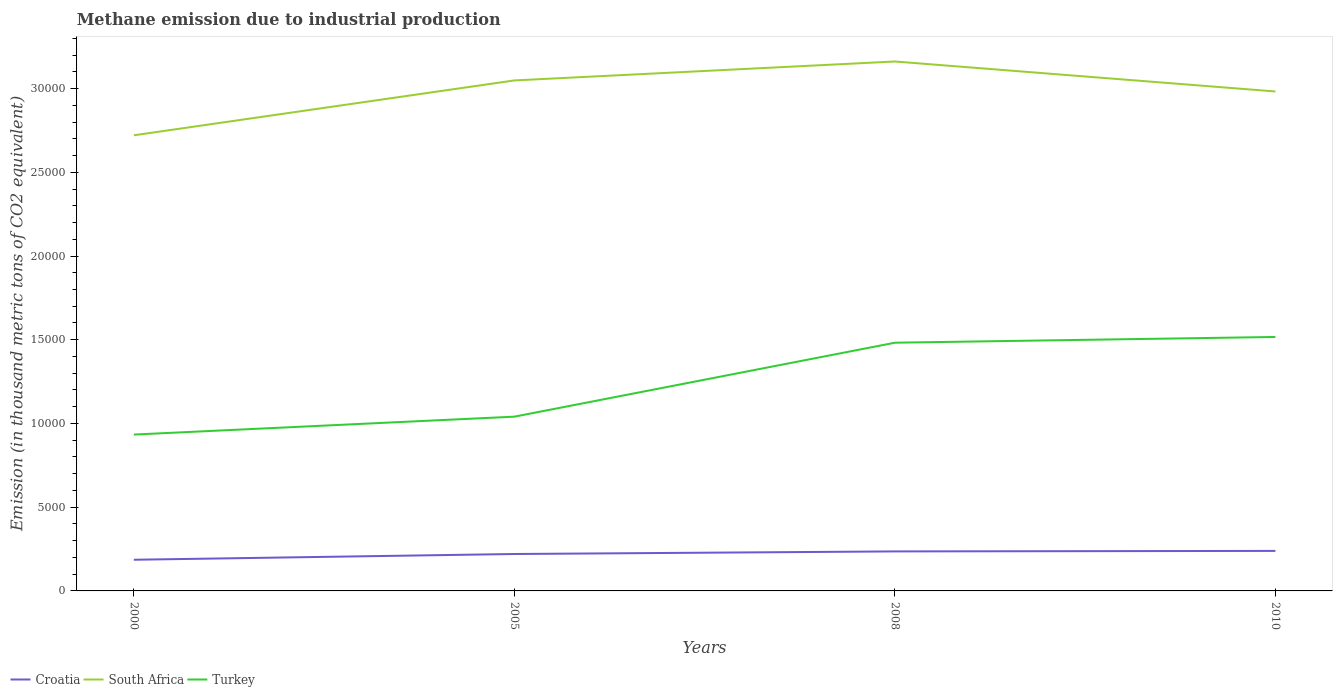Across all years, what is the maximum amount of methane emitted in Croatia?
Offer a very short reply. 1861.7. What is the total amount of methane emitted in Croatia in the graph?
Ensure brevity in your answer.  -184.8. What is the difference between the highest and the second highest amount of methane emitted in Croatia?
Make the answer very short. 527.6. What is the difference between the highest and the lowest amount of methane emitted in Croatia?
Provide a short and direct response. 3. What is the difference between two consecutive major ticks on the Y-axis?
Provide a short and direct response. 5000. Are the values on the major ticks of Y-axis written in scientific E-notation?
Offer a terse response. No. Does the graph contain any zero values?
Your answer should be compact. No. Does the graph contain grids?
Offer a terse response. No. Where does the legend appear in the graph?
Offer a terse response. Bottom left. How are the legend labels stacked?
Offer a terse response. Horizontal. What is the title of the graph?
Offer a very short reply. Methane emission due to industrial production. Does "Andorra" appear as one of the legend labels in the graph?
Your answer should be compact. No. What is the label or title of the X-axis?
Ensure brevity in your answer.  Years. What is the label or title of the Y-axis?
Give a very brief answer. Emission (in thousand metric tons of CO2 equivalent). What is the Emission (in thousand metric tons of CO2 equivalent) of Croatia in 2000?
Give a very brief answer. 1861.7. What is the Emission (in thousand metric tons of CO2 equivalent) of South Africa in 2000?
Make the answer very short. 2.72e+04. What is the Emission (in thousand metric tons of CO2 equivalent) of Turkey in 2000?
Ensure brevity in your answer.  9337. What is the Emission (in thousand metric tons of CO2 equivalent) in Croatia in 2005?
Your answer should be compact. 2204.5. What is the Emission (in thousand metric tons of CO2 equivalent) in South Africa in 2005?
Your response must be concise. 3.05e+04. What is the Emission (in thousand metric tons of CO2 equivalent) in Turkey in 2005?
Make the answer very short. 1.04e+04. What is the Emission (in thousand metric tons of CO2 equivalent) in Croatia in 2008?
Give a very brief answer. 2359.2. What is the Emission (in thousand metric tons of CO2 equivalent) of South Africa in 2008?
Give a very brief answer. 3.16e+04. What is the Emission (in thousand metric tons of CO2 equivalent) in Turkey in 2008?
Make the answer very short. 1.48e+04. What is the Emission (in thousand metric tons of CO2 equivalent) of Croatia in 2010?
Ensure brevity in your answer.  2389.3. What is the Emission (in thousand metric tons of CO2 equivalent) of South Africa in 2010?
Make the answer very short. 2.98e+04. What is the Emission (in thousand metric tons of CO2 equivalent) in Turkey in 2010?
Give a very brief answer. 1.52e+04. Across all years, what is the maximum Emission (in thousand metric tons of CO2 equivalent) of Croatia?
Offer a terse response. 2389.3. Across all years, what is the maximum Emission (in thousand metric tons of CO2 equivalent) of South Africa?
Offer a terse response. 3.16e+04. Across all years, what is the maximum Emission (in thousand metric tons of CO2 equivalent) in Turkey?
Make the answer very short. 1.52e+04. Across all years, what is the minimum Emission (in thousand metric tons of CO2 equivalent) in Croatia?
Offer a terse response. 1861.7. Across all years, what is the minimum Emission (in thousand metric tons of CO2 equivalent) of South Africa?
Give a very brief answer. 2.72e+04. Across all years, what is the minimum Emission (in thousand metric tons of CO2 equivalent) of Turkey?
Provide a succinct answer. 9337. What is the total Emission (in thousand metric tons of CO2 equivalent) of Croatia in the graph?
Offer a very short reply. 8814.7. What is the total Emission (in thousand metric tons of CO2 equivalent) in South Africa in the graph?
Provide a short and direct response. 1.19e+05. What is the total Emission (in thousand metric tons of CO2 equivalent) of Turkey in the graph?
Your answer should be compact. 4.97e+04. What is the difference between the Emission (in thousand metric tons of CO2 equivalent) in Croatia in 2000 and that in 2005?
Offer a terse response. -342.8. What is the difference between the Emission (in thousand metric tons of CO2 equivalent) in South Africa in 2000 and that in 2005?
Your response must be concise. -3276.5. What is the difference between the Emission (in thousand metric tons of CO2 equivalent) of Turkey in 2000 and that in 2005?
Provide a short and direct response. -1069.4. What is the difference between the Emission (in thousand metric tons of CO2 equivalent) of Croatia in 2000 and that in 2008?
Your response must be concise. -497.5. What is the difference between the Emission (in thousand metric tons of CO2 equivalent) in South Africa in 2000 and that in 2008?
Provide a short and direct response. -4407.6. What is the difference between the Emission (in thousand metric tons of CO2 equivalent) of Turkey in 2000 and that in 2008?
Ensure brevity in your answer.  -5485.1. What is the difference between the Emission (in thousand metric tons of CO2 equivalent) in Croatia in 2000 and that in 2010?
Your response must be concise. -527.6. What is the difference between the Emission (in thousand metric tons of CO2 equivalent) of South Africa in 2000 and that in 2010?
Keep it short and to the point. -2616.9. What is the difference between the Emission (in thousand metric tons of CO2 equivalent) of Turkey in 2000 and that in 2010?
Give a very brief answer. -5828.6. What is the difference between the Emission (in thousand metric tons of CO2 equivalent) in Croatia in 2005 and that in 2008?
Your response must be concise. -154.7. What is the difference between the Emission (in thousand metric tons of CO2 equivalent) of South Africa in 2005 and that in 2008?
Your answer should be very brief. -1131.1. What is the difference between the Emission (in thousand metric tons of CO2 equivalent) in Turkey in 2005 and that in 2008?
Give a very brief answer. -4415.7. What is the difference between the Emission (in thousand metric tons of CO2 equivalent) of Croatia in 2005 and that in 2010?
Provide a succinct answer. -184.8. What is the difference between the Emission (in thousand metric tons of CO2 equivalent) in South Africa in 2005 and that in 2010?
Your answer should be compact. 659.6. What is the difference between the Emission (in thousand metric tons of CO2 equivalent) of Turkey in 2005 and that in 2010?
Offer a terse response. -4759.2. What is the difference between the Emission (in thousand metric tons of CO2 equivalent) of Croatia in 2008 and that in 2010?
Offer a terse response. -30.1. What is the difference between the Emission (in thousand metric tons of CO2 equivalent) in South Africa in 2008 and that in 2010?
Make the answer very short. 1790.7. What is the difference between the Emission (in thousand metric tons of CO2 equivalent) in Turkey in 2008 and that in 2010?
Make the answer very short. -343.5. What is the difference between the Emission (in thousand metric tons of CO2 equivalent) of Croatia in 2000 and the Emission (in thousand metric tons of CO2 equivalent) of South Africa in 2005?
Offer a very short reply. -2.86e+04. What is the difference between the Emission (in thousand metric tons of CO2 equivalent) of Croatia in 2000 and the Emission (in thousand metric tons of CO2 equivalent) of Turkey in 2005?
Your answer should be compact. -8544.7. What is the difference between the Emission (in thousand metric tons of CO2 equivalent) in South Africa in 2000 and the Emission (in thousand metric tons of CO2 equivalent) in Turkey in 2005?
Provide a short and direct response. 1.68e+04. What is the difference between the Emission (in thousand metric tons of CO2 equivalent) of Croatia in 2000 and the Emission (in thousand metric tons of CO2 equivalent) of South Africa in 2008?
Keep it short and to the point. -2.98e+04. What is the difference between the Emission (in thousand metric tons of CO2 equivalent) in Croatia in 2000 and the Emission (in thousand metric tons of CO2 equivalent) in Turkey in 2008?
Offer a very short reply. -1.30e+04. What is the difference between the Emission (in thousand metric tons of CO2 equivalent) in South Africa in 2000 and the Emission (in thousand metric tons of CO2 equivalent) in Turkey in 2008?
Provide a succinct answer. 1.24e+04. What is the difference between the Emission (in thousand metric tons of CO2 equivalent) in Croatia in 2000 and the Emission (in thousand metric tons of CO2 equivalent) in South Africa in 2010?
Ensure brevity in your answer.  -2.80e+04. What is the difference between the Emission (in thousand metric tons of CO2 equivalent) in Croatia in 2000 and the Emission (in thousand metric tons of CO2 equivalent) in Turkey in 2010?
Ensure brevity in your answer.  -1.33e+04. What is the difference between the Emission (in thousand metric tons of CO2 equivalent) in South Africa in 2000 and the Emission (in thousand metric tons of CO2 equivalent) in Turkey in 2010?
Offer a very short reply. 1.20e+04. What is the difference between the Emission (in thousand metric tons of CO2 equivalent) of Croatia in 2005 and the Emission (in thousand metric tons of CO2 equivalent) of South Africa in 2008?
Provide a succinct answer. -2.94e+04. What is the difference between the Emission (in thousand metric tons of CO2 equivalent) of Croatia in 2005 and the Emission (in thousand metric tons of CO2 equivalent) of Turkey in 2008?
Provide a succinct answer. -1.26e+04. What is the difference between the Emission (in thousand metric tons of CO2 equivalent) in South Africa in 2005 and the Emission (in thousand metric tons of CO2 equivalent) in Turkey in 2008?
Provide a succinct answer. 1.57e+04. What is the difference between the Emission (in thousand metric tons of CO2 equivalent) of Croatia in 2005 and the Emission (in thousand metric tons of CO2 equivalent) of South Africa in 2010?
Your answer should be very brief. -2.76e+04. What is the difference between the Emission (in thousand metric tons of CO2 equivalent) of Croatia in 2005 and the Emission (in thousand metric tons of CO2 equivalent) of Turkey in 2010?
Keep it short and to the point. -1.30e+04. What is the difference between the Emission (in thousand metric tons of CO2 equivalent) in South Africa in 2005 and the Emission (in thousand metric tons of CO2 equivalent) in Turkey in 2010?
Ensure brevity in your answer.  1.53e+04. What is the difference between the Emission (in thousand metric tons of CO2 equivalent) of Croatia in 2008 and the Emission (in thousand metric tons of CO2 equivalent) of South Africa in 2010?
Your answer should be compact. -2.75e+04. What is the difference between the Emission (in thousand metric tons of CO2 equivalent) in Croatia in 2008 and the Emission (in thousand metric tons of CO2 equivalent) in Turkey in 2010?
Offer a very short reply. -1.28e+04. What is the difference between the Emission (in thousand metric tons of CO2 equivalent) in South Africa in 2008 and the Emission (in thousand metric tons of CO2 equivalent) in Turkey in 2010?
Your response must be concise. 1.64e+04. What is the average Emission (in thousand metric tons of CO2 equivalent) in Croatia per year?
Offer a very short reply. 2203.68. What is the average Emission (in thousand metric tons of CO2 equivalent) in South Africa per year?
Your response must be concise. 2.98e+04. What is the average Emission (in thousand metric tons of CO2 equivalent) of Turkey per year?
Provide a short and direct response. 1.24e+04. In the year 2000, what is the difference between the Emission (in thousand metric tons of CO2 equivalent) in Croatia and Emission (in thousand metric tons of CO2 equivalent) in South Africa?
Offer a terse response. -2.53e+04. In the year 2000, what is the difference between the Emission (in thousand metric tons of CO2 equivalent) of Croatia and Emission (in thousand metric tons of CO2 equivalent) of Turkey?
Keep it short and to the point. -7475.3. In the year 2000, what is the difference between the Emission (in thousand metric tons of CO2 equivalent) of South Africa and Emission (in thousand metric tons of CO2 equivalent) of Turkey?
Offer a terse response. 1.79e+04. In the year 2005, what is the difference between the Emission (in thousand metric tons of CO2 equivalent) in Croatia and Emission (in thousand metric tons of CO2 equivalent) in South Africa?
Give a very brief answer. -2.83e+04. In the year 2005, what is the difference between the Emission (in thousand metric tons of CO2 equivalent) in Croatia and Emission (in thousand metric tons of CO2 equivalent) in Turkey?
Offer a terse response. -8201.9. In the year 2005, what is the difference between the Emission (in thousand metric tons of CO2 equivalent) of South Africa and Emission (in thousand metric tons of CO2 equivalent) of Turkey?
Make the answer very short. 2.01e+04. In the year 2008, what is the difference between the Emission (in thousand metric tons of CO2 equivalent) of Croatia and Emission (in thousand metric tons of CO2 equivalent) of South Africa?
Make the answer very short. -2.93e+04. In the year 2008, what is the difference between the Emission (in thousand metric tons of CO2 equivalent) in Croatia and Emission (in thousand metric tons of CO2 equivalent) in Turkey?
Your answer should be compact. -1.25e+04. In the year 2008, what is the difference between the Emission (in thousand metric tons of CO2 equivalent) of South Africa and Emission (in thousand metric tons of CO2 equivalent) of Turkey?
Keep it short and to the point. 1.68e+04. In the year 2010, what is the difference between the Emission (in thousand metric tons of CO2 equivalent) of Croatia and Emission (in thousand metric tons of CO2 equivalent) of South Africa?
Your answer should be compact. -2.74e+04. In the year 2010, what is the difference between the Emission (in thousand metric tons of CO2 equivalent) in Croatia and Emission (in thousand metric tons of CO2 equivalent) in Turkey?
Your answer should be very brief. -1.28e+04. In the year 2010, what is the difference between the Emission (in thousand metric tons of CO2 equivalent) of South Africa and Emission (in thousand metric tons of CO2 equivalent) of Turkey?
Make the answer very short. 1.47e+04. What is the ratio of the Emission (in thousand metric tons of CO2 equivalent) in Croatia in 2000 to that in 2005?
Your response must be concise. 0.84. What is the ratio of the Emission (in thousand metric tons of CO2 equivalent) in South Africa in 2000 to that in 2005?
Keep it short and to the point. 0.89. What is the ratio of the Emission (in thousand metric tons of CO2 equivalent) in Turkey in 2000 to that in 2005?
Make the answer very short. 0.9. What is the ratio of the Emission (in thousand metric tons of CO2 equivalent) in Croatia in 2000 to that in 2008?
Your answer should be very brief. 0.79. What is the ratio of the Emission (in thousand metric tons of CO2 equivalent) in South Africa in 2000 to that in 2008?
Offer a terse response. 0.86. What is the ratio of the Emission (in thousand metric tons of CO2 equivalent) of Turkey in 2000 to that in 2008?
Provide a succinct answer. 0.63. What is the ratio of the Emission (in thousand metric tons of CO2 equivalent) in Croatia in 2000 to that in 2010?
Your response must be concise. 0.78. What is the ratio of the Emission (in thousand metric tons of CO2 equivalent) in South Africa in 2000 to that in 2010?
Provide a short and direct response. 0.91. What is the ratio of the Emission (in thousand metric tons of CO2 equivalent) of Turkey in 2000 to that in 2010?
Your answer should be compact. 0.62. What is the ratio of the Emission (in thousand metric tons of CO2 equivalent) in Croatia in 2005 to that in 2008?
Provide a short and direct response. 0.93. What is the ratio of the Emission (in thousand metric tons of CO2 equivalent) of South Africa in 2005 to that in 2008?
Make the answer very short. 0.96. What is the ratio of the Emission (in thousand metric tons of CO2 equivalent) in Turkey in 2005 to that in 2008?
Keep it short and to the point. 0.7. What is the ratio of the Emission (in thousand metric tons of CO2 equivalent) of Croatia in 2005 to that in 2010?
Ensure brevity in your answer.  0.92. What is the ratio of the Emission (in thousand metric tons of CO2 equivalent) of South Africa in 2005 to that in 2010?
Offer a terse response. 1.02. What is the ratio of the Emission (in thousand metric tons of CO2 equivalent) in Turkey in 2005 to that in 2010?
Your response must be concise. 0.69. What is the ratio of the Emission (in thousand metric tons of CO2 equivalent) in Croatia in 2008 to that in 2010?
Provide a succinct answer. 0.99. What is the ratio of the Emission (in thousand metric tons of CO2 equivalent) of South Africa in 2008 to that in 2010?
Give a very brief answer. 1.06. What is the ratio of the Emission (in thousand metric tons of CO2 equivalent) of Turkey in 2008 to that in 2010?
Offer a very short reply. 0.98. What is the difference between the highest and the second highest Emission (in thousand metric tons of CO2 equivalent) of Croatia?
Provide a succinct answer. 30.1. What is the difference between the highest and the second highest Emission (in thousand metric tons of CO2 equivalent) of South Africa?
Give a very brief answer. 1131.1. What is the difference between the highest and the second highest Emission (in thousand metric tons of CO2 equivalent) in Turkey?
Provide a succinct answer. 343.5. What is the difference between the highest and the lowest Emission (in thousand metric tons of CO2 equivalent) in Croatia?
Provide a succinct answer. 527.6. What is the difference between the highest and the lowest Emission (in thousand metric tons of CO2 equivalent) of South Africa?
Ensure brevity in your answer.  4407.6. What is the difference between the highest and the lowest Emission (in thousand metric tons of CO2 equivalent) of Turkey?
Offer a terse response. 5828.6. 